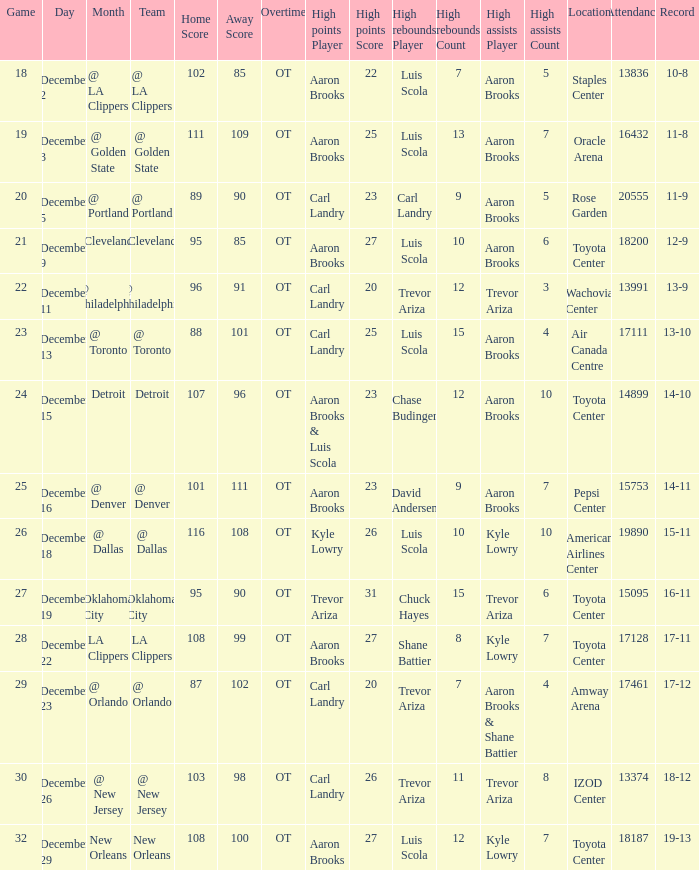What's the end score of the game where Shane Battier (8) did the high rebounds? W 108–99 (OT). 